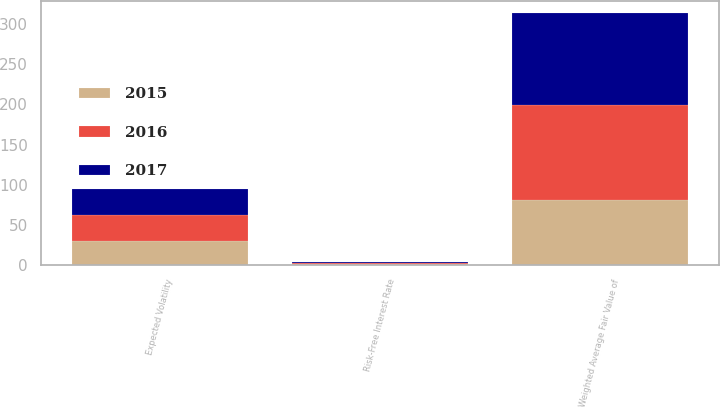<chart> <loc_0><loc_0><loc_500><loc_500><stacked_bar_chart><ecel><fcel>Weighted Average Fair Value of<fcel>Expected Volatility<fcel>Risk-Free Interest Rate<nl><fcel>2017<fcel>113.81<fcel>32.19<fcel>1.6<nl><fcel>2016<fcel>119.1<fcel>32.48<fcel>1.15<nl><fcel>2015<fcel>80.64<fcel>29.35<fcel>1.07<nl></chart> 